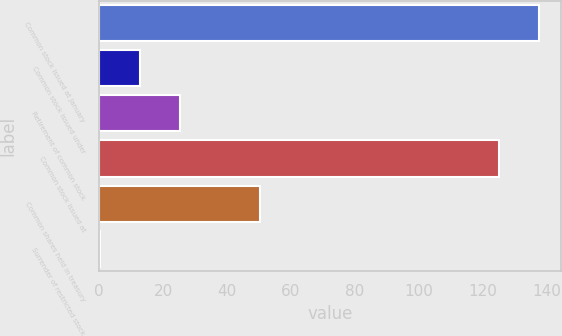<chart> <loc_0><loc_0><loc_500><loc_500><bar_chart><fcel>Common stock issued at January<fcel>Common stock issued under<fcel>Retirement of common stock<fcel>Common stock issued at<fcel>Common shares held in treasury<fcel>Surrender of restricted stock<nl><fcel>137.63<fcel>12.83<fcel>25.36<fcel>125.1<fcel>50.42<fcel>0.3<nl></chart> 